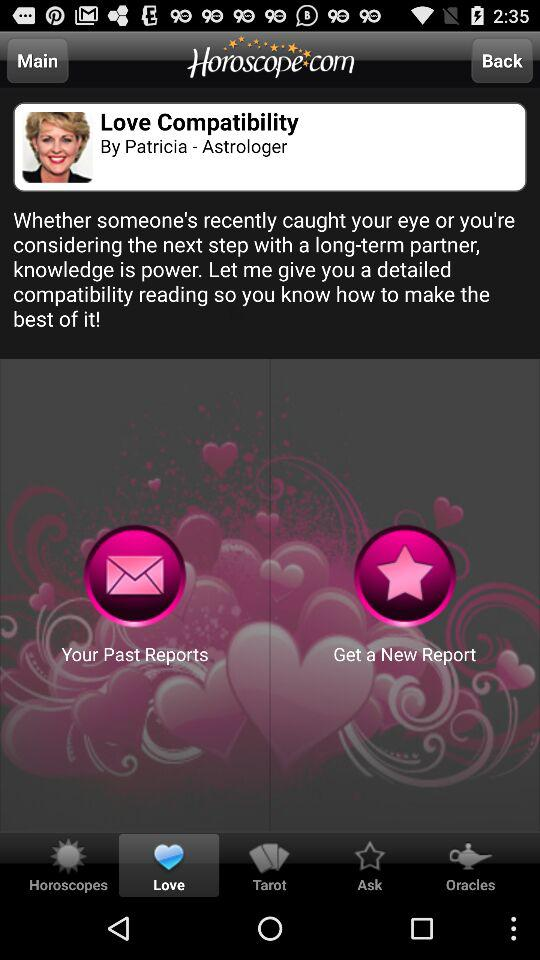Which astrological sign is selected?
When the provided information is insufficient, respond with <no answer>. <no answer> 